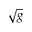Convert formula to latex. <formula><loc_0><loc_0><loc_500><loc_500>\sqrt { g }</formula> 